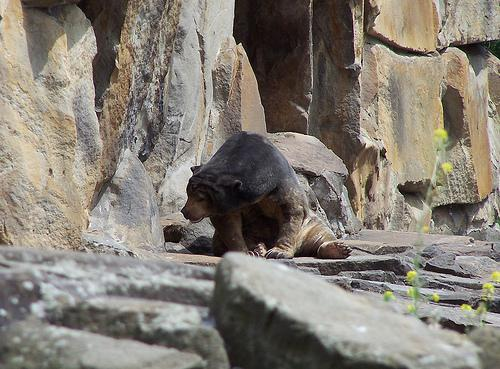Question: why is it so bright?
Choices:
A. Fire.
B. Spotlights.
C. Flashbulbs.
D. Sunny.
Answer with the letter. Answer: D Question: when was the photo taken?
Choices:
A. At graduation.
B. At wedding.
C. Day time.
D. A daybreak.
Answer with the letter. Answer: C Question: where was the photo taken?
Choices:
A. At a beach.
B. In the jungle.
C. At the zoo.
D. In a park.
Answer with the letter. Answer: C 